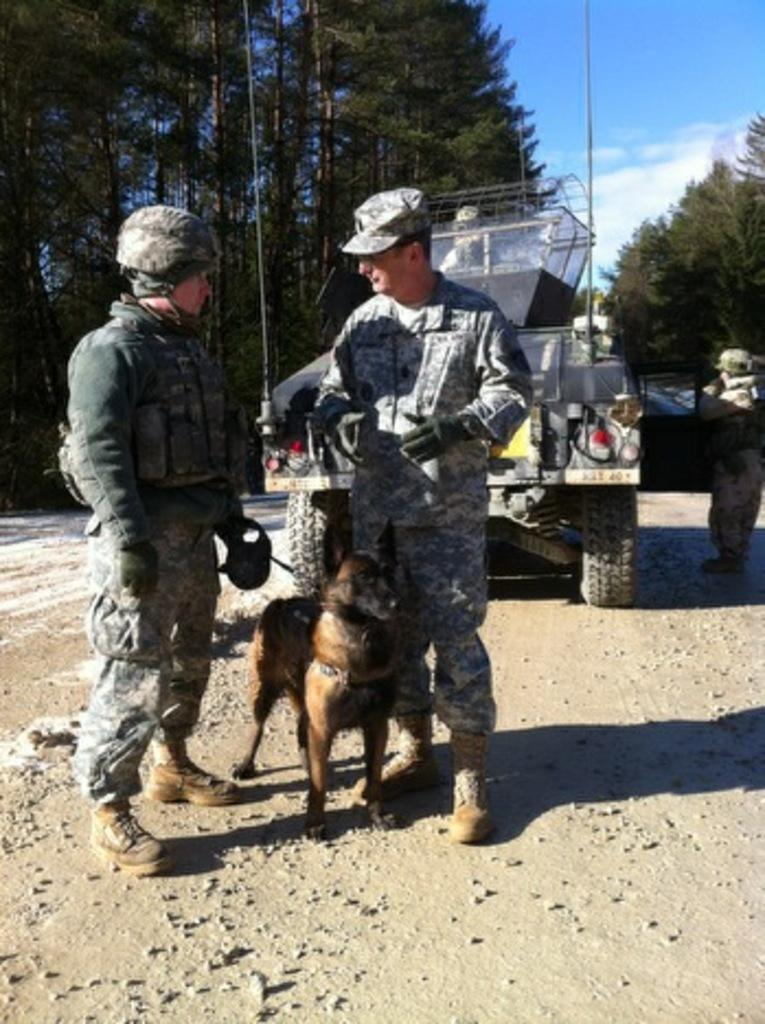How many people are in the image? There are two men in the image. What is located in the middle of the image? There is a dog in the middle of the image. What can be seen in the background of the image? There is a van and trees in the background of the image. What is visible at the top of the image? The sky is visible at the top of the image. What type of bone is the dog chewing on in the image? There is no bone present in the image; the dog is not chewing on anything. What topic are the two men discussing in the image? The image does not provide any information about a discussion between the two men. 